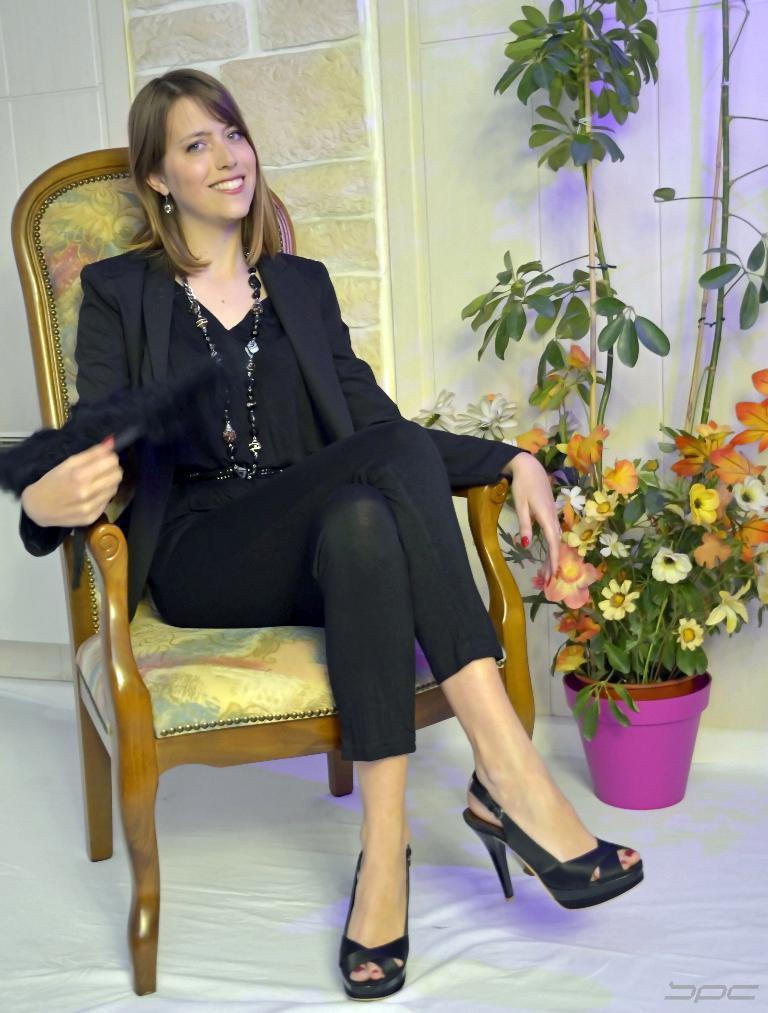Describe this image in one or two sentences. In the middle of the image a woman is sitting on a chair and smiling. Behind her there is a wall. Bottom right side of the image there is a plant. 